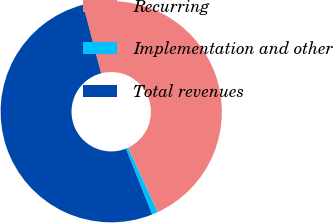Convert chart. <chart><loc_0><loc_0><loc_500><loc_500><pie_chart><fcel>Recurring<fcel>Implementation and other<fcel>Total revenues<nl><fcel>47.21%<fcel>0.87%<fcel>51.93%<nl></chart> 